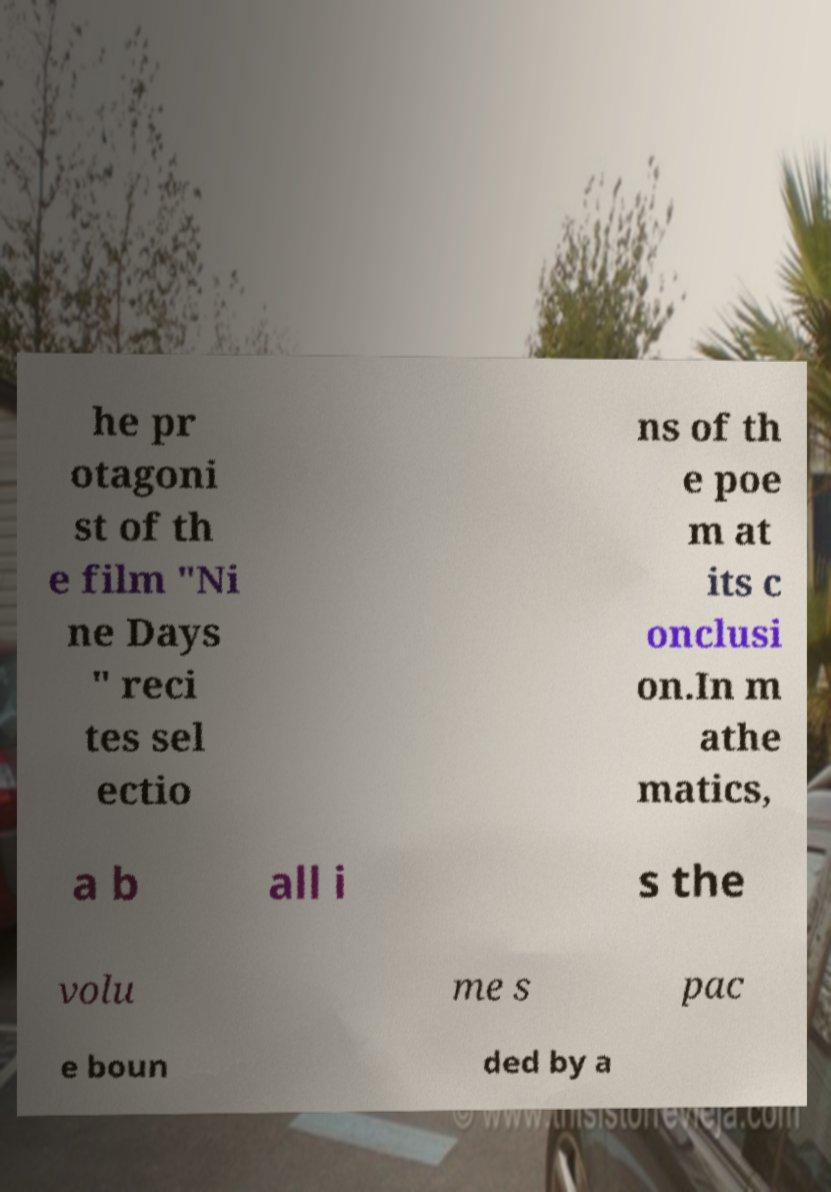Please read and relay the text visible in this image. What does it say? he pr otagoni st of th e film "Ni ne Days " reci tes sel ectio ns of th e poe m at its c onclusi on.In m athe matics, a b all i s the volu me s pac e boun ded by a 